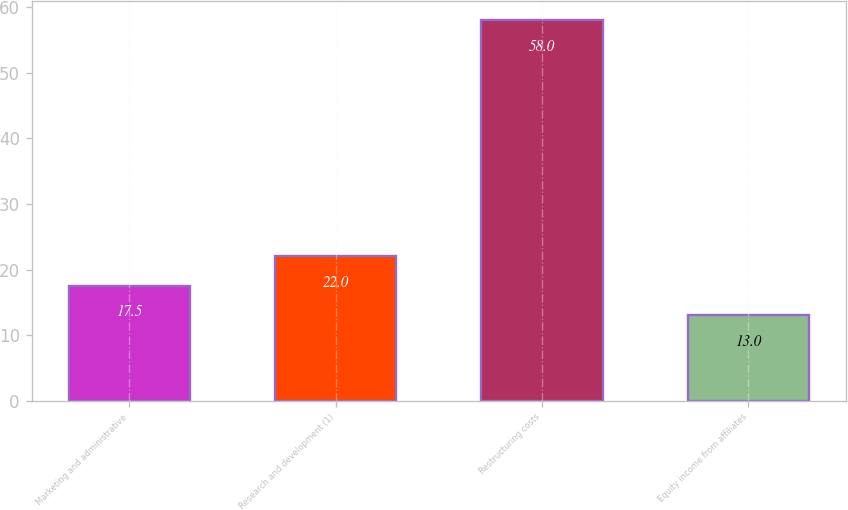<chart> <loc_0><loc_0><loc_500><loc_500><bar_chart><fcel>Marketing and administrative<fcel>Research and development (1)<fcel>Restructuring costs<fcel>Equity income from affiliates<nl><fcel>17.5<fcel>22<fcel>58<fcel>13<nl></chart> 